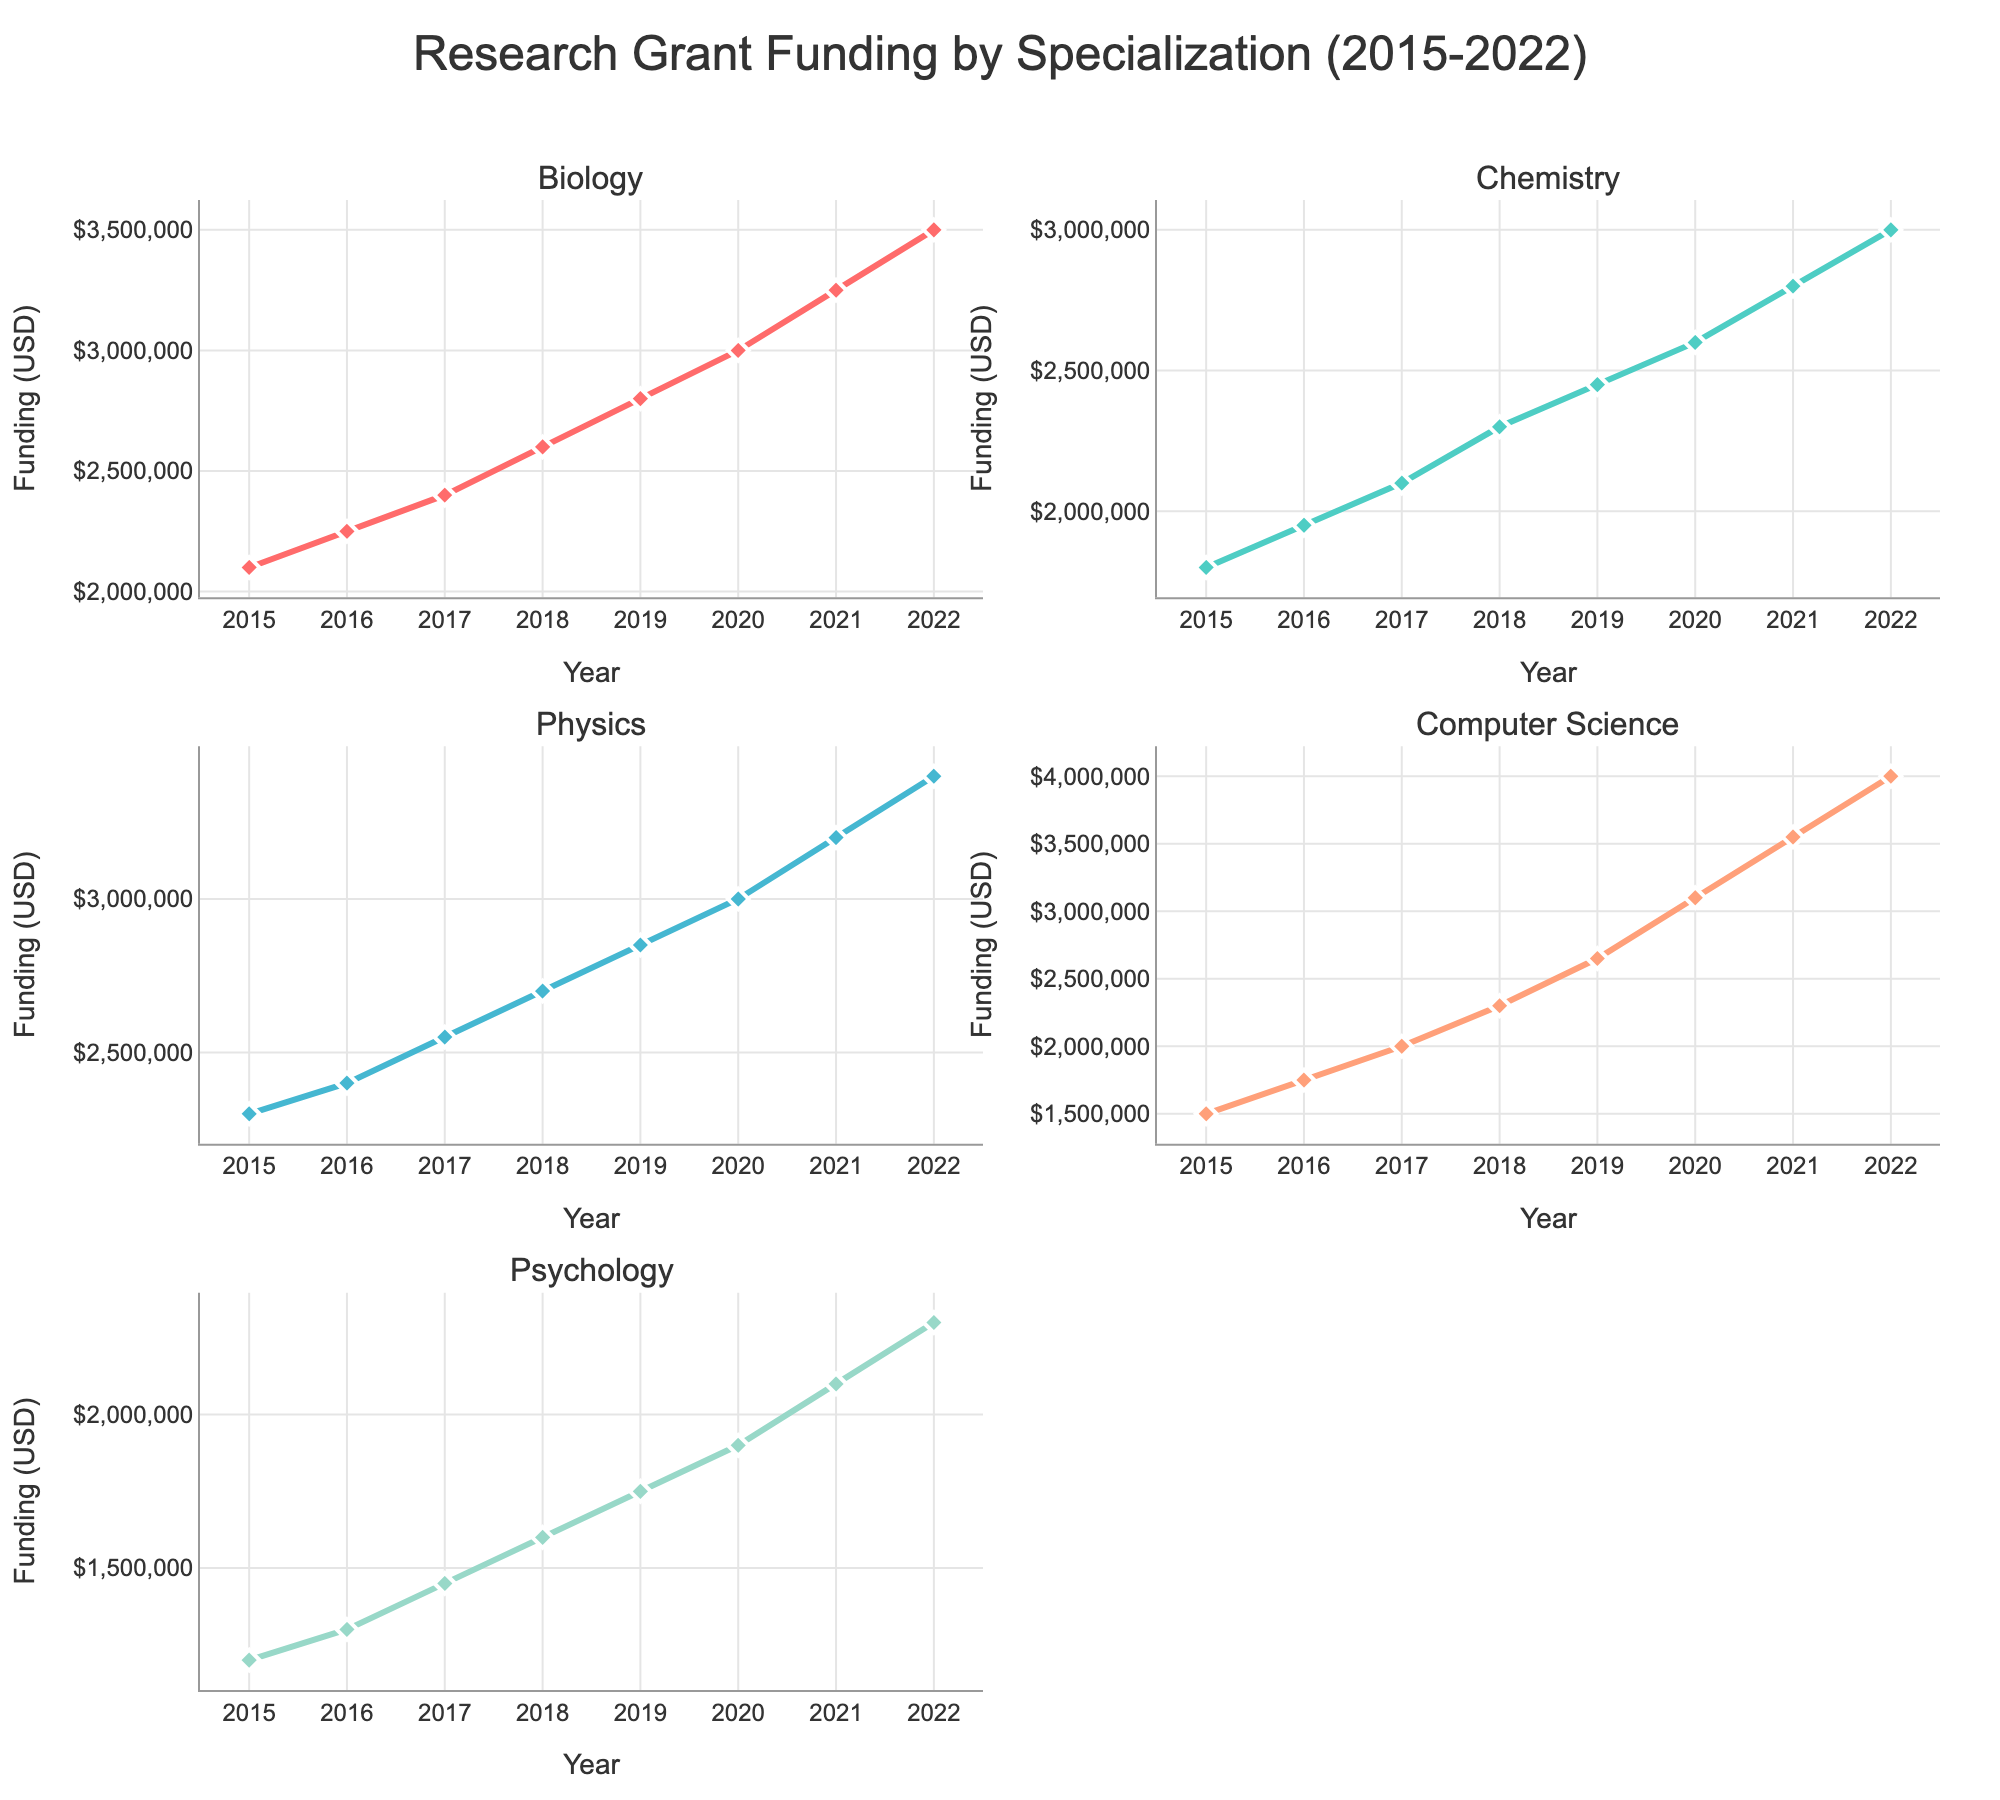How many specializations are shown in the figure? The figure displays multiple subplots each titled with a specialization. Counting these titles reveals the number of specializations.
Answer: 5 What does the y-axis represent in each subplot? In each subplot, the y-axis is labeled "Funding (USD)," indicating that it measures the amount of research grant funding in dollars.
Answer: Research grant funding in USD Which specialization had the highest funding in 2022? The line chart for each specialization displays funding amounts for each year up to 2022. By looking at the highest point on the graph for 2022 across all subplots, Computer Science stands out.
Answer: Computer Science In which year did Biology receive the highest research funding? By observing the peak value in the Biology subplot, the highest point occurs in 2022.
Answer: 2022 What was the funding amount for Chemistry in 2017? The value can be read directly from the Chemistry subplot at the year 2017 point on the x-axis.
Answer: $2,100,000 How much did Physics funding increase from 2019 to 2022? Identify funding values for Physics in 2019 ($2,850,000) and 2022 ($3,400,000), then subtract the former from the latter: $3,400,000 - $2,850,000 = $550,000.
Answer: $550,000 Which specialization experienced the largest increase in funding from 2015 to 2022? Calculate the increase for each specialization by subtracting 2015 values from 2022: Biology ($3,500,000 - $2,100,000), Chemistry ($3,000,000 - $1,800,000), Physics ($3,400,000 - $2,300,000), Computer Science ($4,000,000 - $1,500,000), and Psychology ($2,300,000 - $1,200,000). Computer Science shows the largest increase ($2,500,000).
Answer: Computer Science Which year saw the maximum total funding across all specializations? Sum the funding amounts for each specialization for each year and identify the year with the highest total: 2022 ($3,500,000 + $3,000,000 + $3,400,000 + $4,000,000 + $2,300,000 = $16,200,000 > other years).
Answer: 2022 When did Psychology funding first exceed $2,000,000? By following the trend line in the Psychology subplot, it is clear the funding first exceeds $2,000,000 in 2021.
Answer: 2021 What was the trend in Chemistry funding between 2015 and 2022? Observe the Chemistry subplot line trend from 2015 to 2022. It consistently increases, showing a clear upward trend.
Answer: Increasing How does the funding for Biology in 2020 compare with Chemistry in the same year? Locate 2020 values for both subplots: Biology ($3,000,000) and Chemistry ($2,600,000). Biology has higher funding.
Answer: Biology has higher funding 